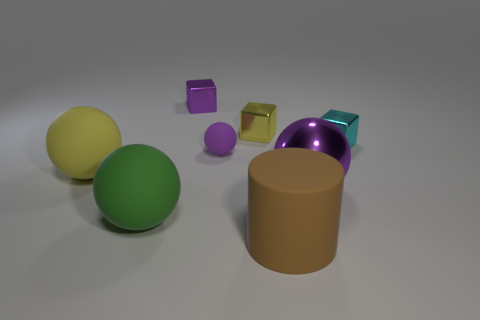There is a sphere that is in front of the purple shiny object that is in front of the cyan metallic cube; how big is it?
Ensure brevity in your answer.  Large. What is the material of the big object that is behind the big green thing and on the right side of the tiny purple metal object?
Your response must be concise. Metal. Is the size of the brown rubber cylinder the same as the yellow thing that is right of the small matte sphere?
Offer a very short reply. No. Is there a matte cylinder?
Ensure brevity in your answer.  Yes. What material is the other purple thing that is the same shape as the small purple rubber thing?
Give a very brief answer. Metal. What is the size of the purple ball that is in front of the big yellow thing that is in front of the purple object that is on the left side of the small purple sphere?
Provide a succinct answer. Large. Are there any large purple metallic balls in front of the large purple object?
Provide a short and direct response. No. What is the size of the ball that is the same material as the cyan object?
Your answer should be compact. Large. What number of big yellow matte objects are the same shape as the tiny cyan metallic thing?
Your response must be concise. 0. Is the large yellow sphere made of the same material as the small purple thing on the right side of the tiny purple block?
Your answer should be very brief. Yes. 